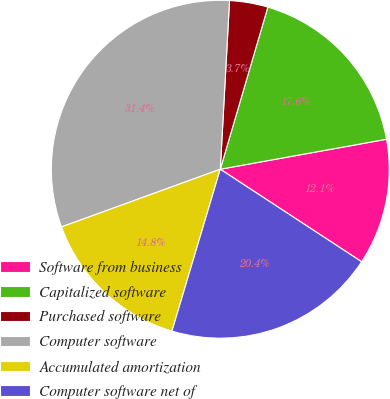<chart> <loc_0><loc_0><loc_500><loc_500><pie_chart><fcel>Software from business<fcel>Capitalized software<fcel>Purchased software<fcel>Computer software<fcel>Accumulated amortization<fcel>Computer software net of<nl><fcel>12.07%<fcel>17.62%<fcel>3.67%<fcel>31.42%<fcel>14.84%<fcel>20.39%<nl></chart> 